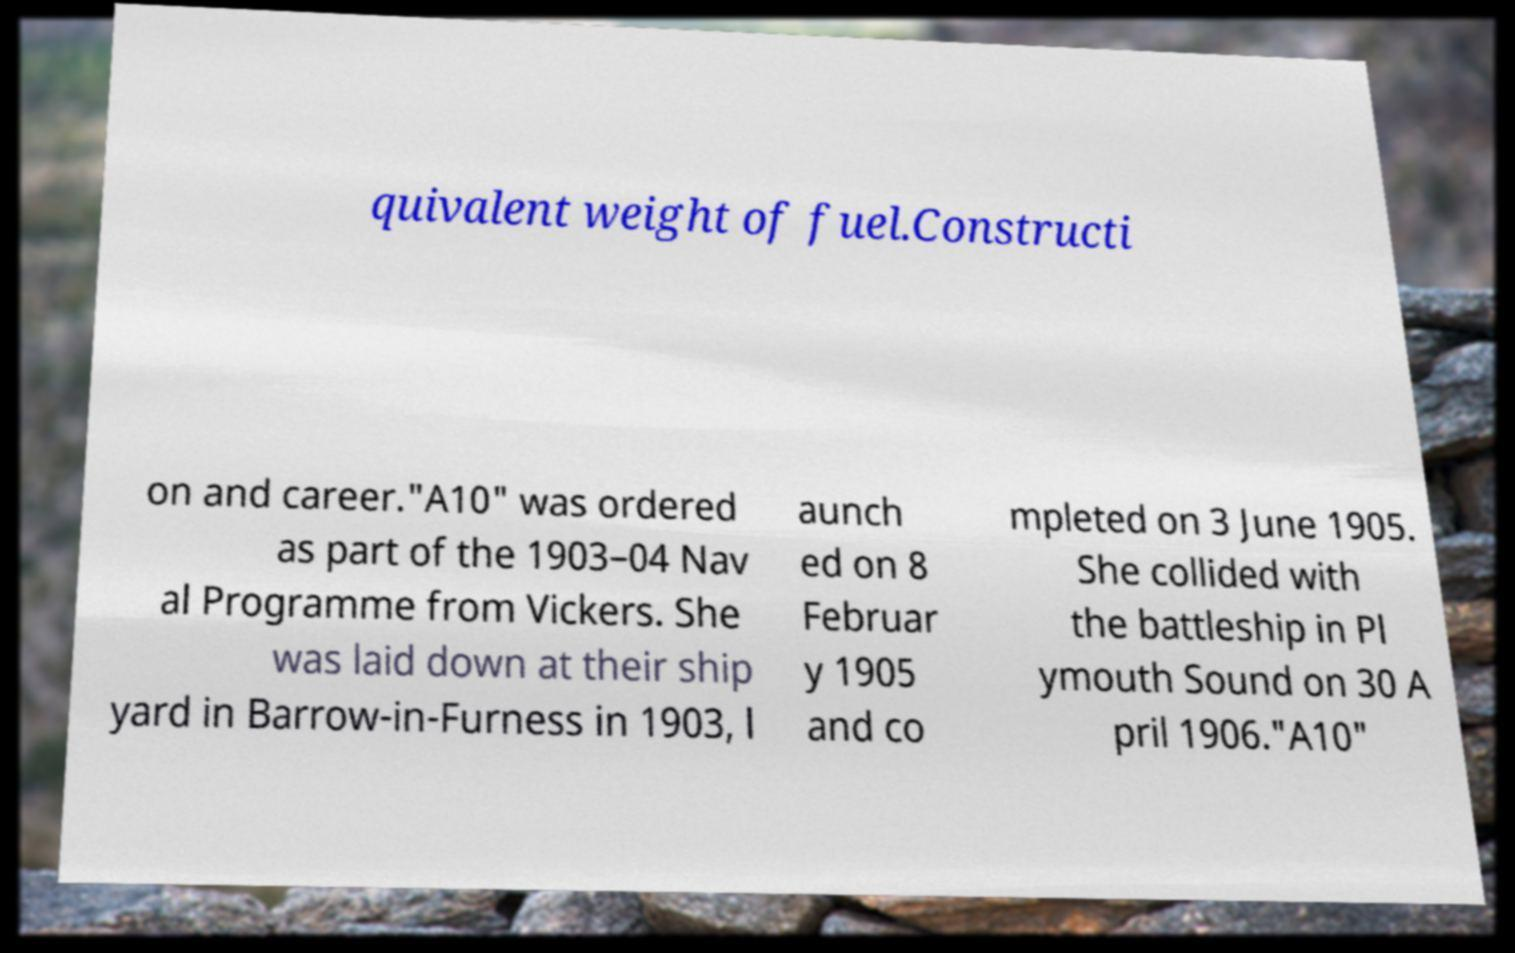Please identify and transcribe the text found in this image. quivalent weight of fuel.Constructi on and career."A10" was ordered as part of the 1903–04 Nav al Programme from Vickers. She was laid down at their ship yard in Barrow-in-Furness in 1903, l aunch ed on 8 Februar y 1905 and co mpleted on 3 June 1905. She collided with the battleship in Pl ymouth Sound on 30 A pril 1906."A10" 